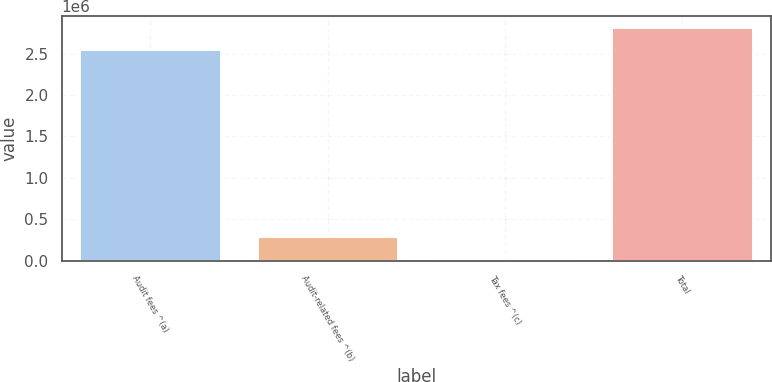<chart> <loc_0><loc_0><loc_500><loc_500><bar_chart><fcel>Audit fees ^(a)<fcel>Audit-related fees ^(b)<fcel>Tax fees ^(c)<fcel>Total<nl><fcel>2.559e+06<fcel>292800<fcel>33000<fcel>2.8188e+06<nl></chart> 